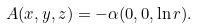Convert formula to latex. <formula><loc_0><loc_0><loc_500><loc_500>A ( x , y , z ) = - \alpha ( 0 , 0 , \ln r ) .</formula> 